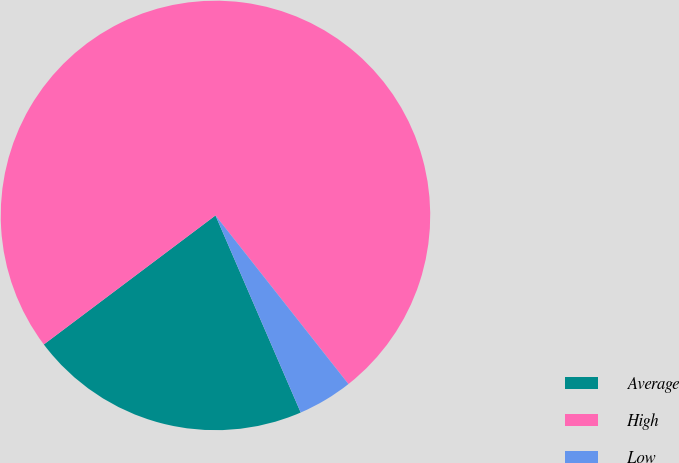Convert chart. <chart><loc_0><loc_0><loc_500><loc_500><pie_chart><fcel>Average<fcel>High<fcel>Low<nl><fcel>21.24%<fcel>74.63%<fcel>4.13%<nl></chart> 